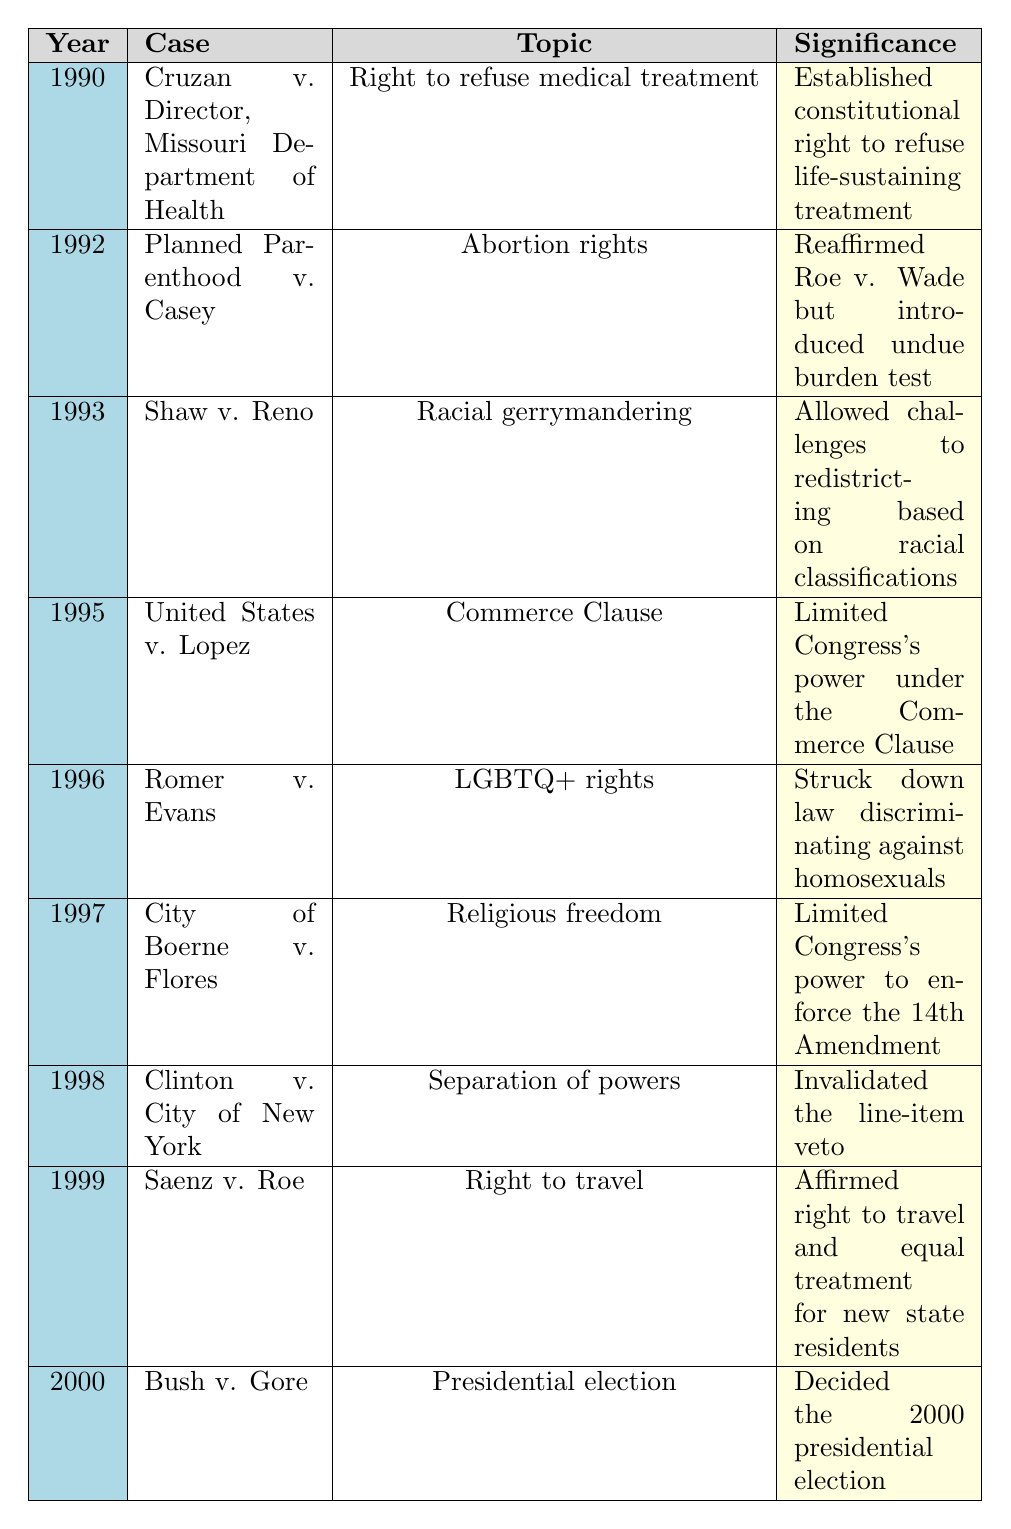What year did the case "Clinton v. City of New York" occur? Referring to the table, the specific row for "Clinton v. City of New York" shows that it took place in 1998.
Answer: 1998 What topic is covered by the case "Romer v. Evans"? The table lists "Romer v. Evans" and identifies its topic as "LGBTQ+ rights."
Answer: LGBTQ+ rights Which case was decided in the year 1995? Looking at the row for 1995 in the table, it shows "United States v. Lopez" as the case for that year.
Answer: United States v. Lopez What significant legal principle was established by "Cruzan v. Director, Missouri Department of Health"? The significance column for "Cruzan v. Director, Missouri Department of Health" states that it established a constitutional right to refuse life-sustaining treatment.
Answer: Established constitutional right to refuse life-sustaining treatment Which two cases addressed issues related to personal rights and liberties? By examining the topics associated with cases, "Planned Parenthood v. Casey" (abortion rights) and "Romer v. Evans" (LGBTQ+ rights) both address personal rights.
Answer: Planned Parenthood v. Casey and Romer v. Evans How many cases were decided between 1990 and 1995? The table lists cases from 1990 to 1995, counting them gives a total of 6 cases (Cruzan, Planned Parenthood, Shaw, United States, Romer, City of Boerne).
Answer: 6 Did the case "Saenz v. Roe" affirm a right related to travel? According to the significance of "Saenz v. Roe," it affirmed the right to travel and equal treatment for new state residents, indicating that it does affirm such a right.
Answer: Yes Which case limited Congress's power under the Commerce Clause? Referring to the table, "United States v. Lopez" is specifically listed under the significance of limiting Congress's power under the Commerce Clause.
Answer: United States v. Lopez What was the outcome of "Bush v. Gore"? The significance of "Bush v. Gore" states that it decided the 2000 presidential election, indicating its outcome.
Answer: Decided the 2000 presidential election Arrange the cases by increasing year and identify the one that deals with separation of powers. By reviewing the chronological ordering in the table, "Clinton v. City of New York" (1998) is identified and matches the requirement regarding separation of powers.
Answer: Clinton v. City of New York Which case established an undue burden test related to abortion? The table indicates that "Planned Parenthood v. Casey" reaffirmed Roe v. Wade and introduced the undue burden test, establishing its relation to abortion rights.
Answer: Planned Parenthood v. Casey 